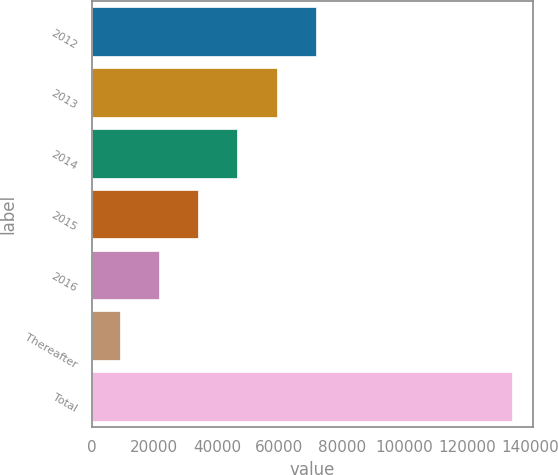Convert chart. <chart><loc_0><loc_0><loc_500><loc_500><bar_chart><fcel>2012<fcel>2013<fcel>2014<fcel>2015<fcel>2016<fcel>Thereafter<fcel>Total<nl><fcel>71651<fcel>59110.2<fcel>46569.4<fcel>34028.6<fcel>21487.8<fcel>8947<fcel>134355<nl></chart> 